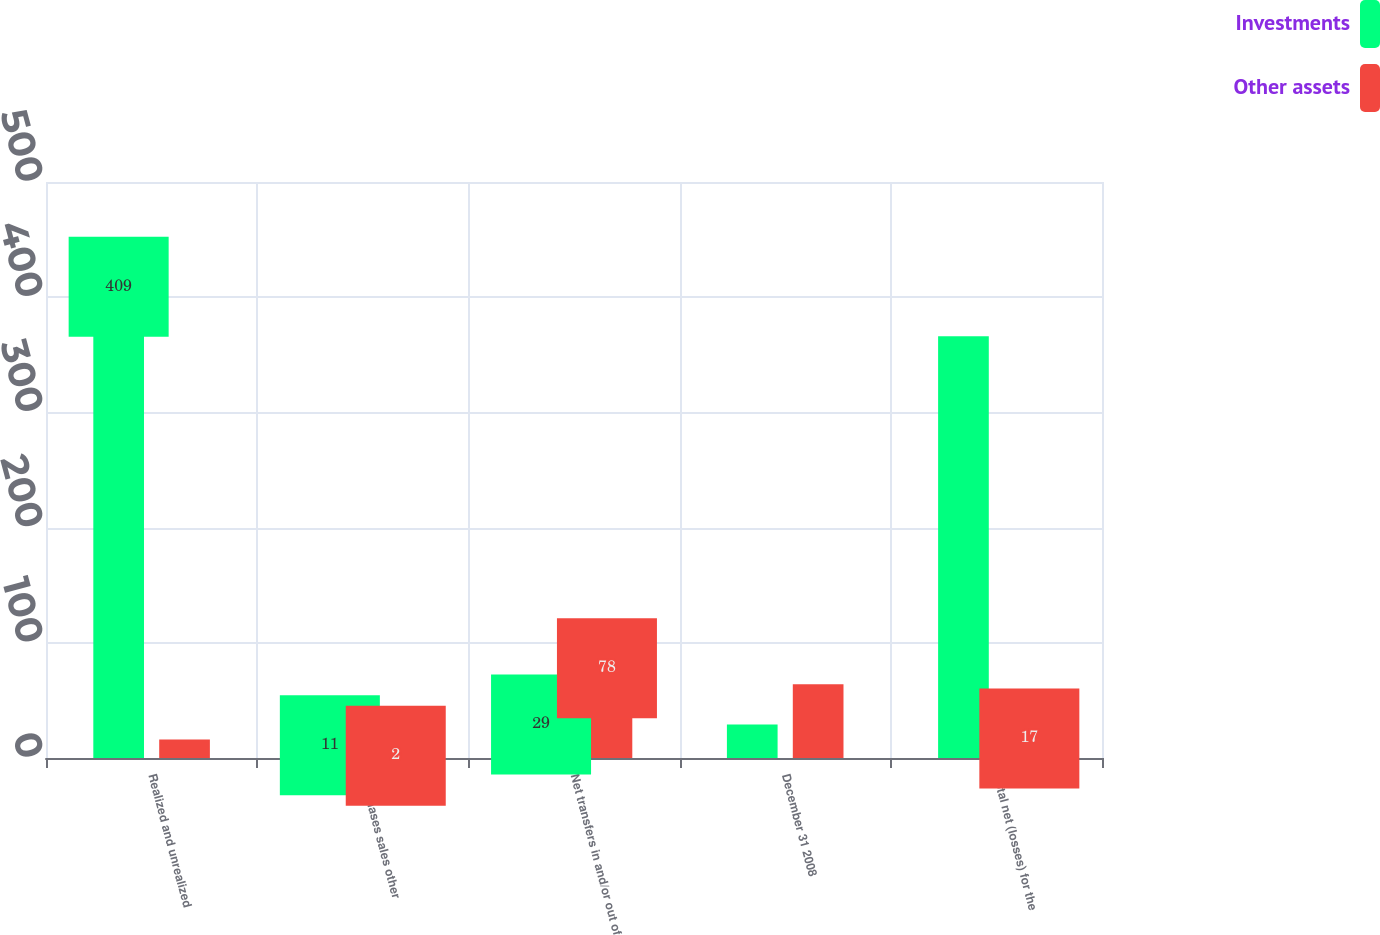Convert chart. <chart><loc_0><loc_0><loc_500><loc_500><stacked_bar_chart><ecel><fcel>Realized and unrealized<fcel>Purchases sales other<fcel>Net transfers in and/or out of<fcel>December 31 2008<fcel>Total net (losses) for the<nl><fcel>Investments<fcel>409<fcel>11<fcel>29<fcel>29<fcel>366<nl><fcel>Other assets<fcel>16<fcel>2<fcel>78<fcel>64<fcel>17<nl></chart> 